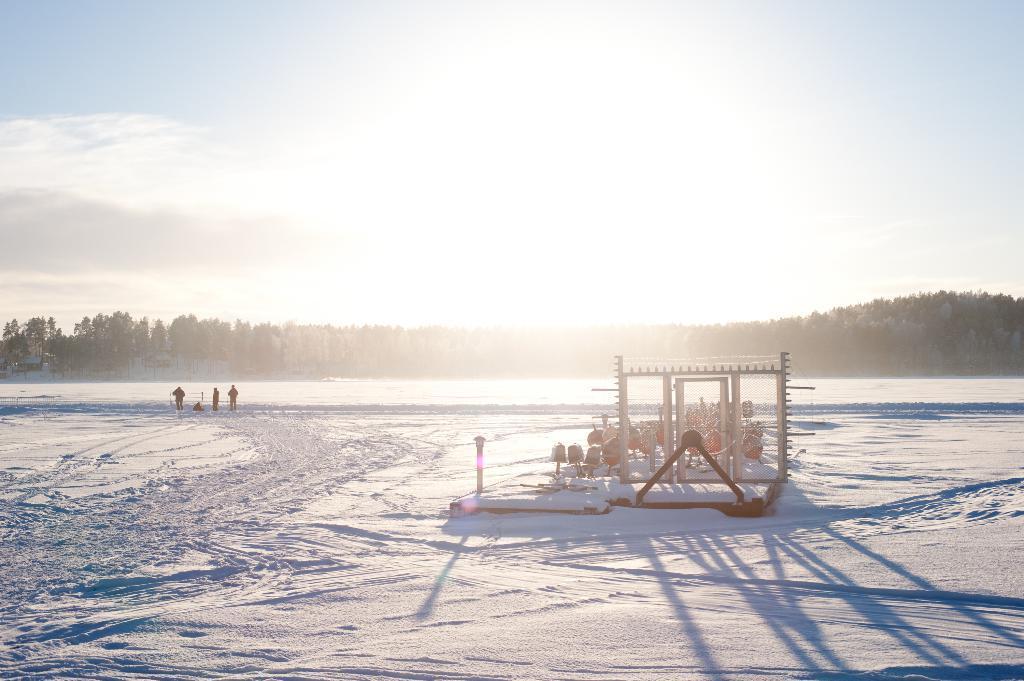Can you describe this image briefly? In the picture I can see people standing on the snow. I can also see some objects on the snow. In the background I can see trees, the sun and the sky. 